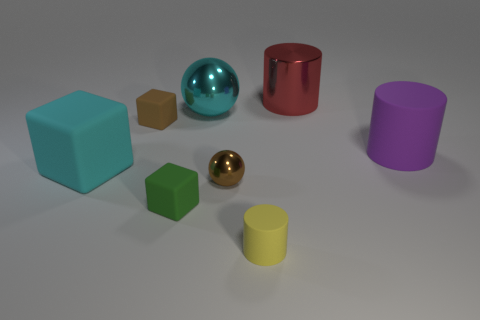What number of spheres are large rubber objects or small green objects?
Your response must be concise. 0. What number of things are right of the cyan rubber object and left of the big red metallic cylinder?
Give a very brief answer. 5. There is a small rubber cube in front of the brown shiny ball; what is its color?
Your response must be concise. Green. The brown thing that is made of the same material as the small yellow thing is what size?
Make the answer very short. Small. There is a matte object right of the small yellow cylinder; how many purple matte cylinders are to the right of it?
Keep it short and to the point. 0. There is a tiny brown rubber cube; how many tiny yellow cylinders are in front of it?
Provide a succinct answer. 1. What color is the shiny object to the right of the cylinder in front of the matte cube right of the small brown matte object?
Make the answer very short. Red. Is the color of the ball that is in front of the brown rubber object the same as the tiny rubber thing behind the green cube?
Make the answer very short. Yes. There is a big matte thing that is to the right of the cylinder that is on the left side of the big red cylinder; what is its shape?
Your answer should be very brief. Cylinder. Is there a cyan rubber object of the same size as the yellow cylinder?
Give a very brief answer. No. 